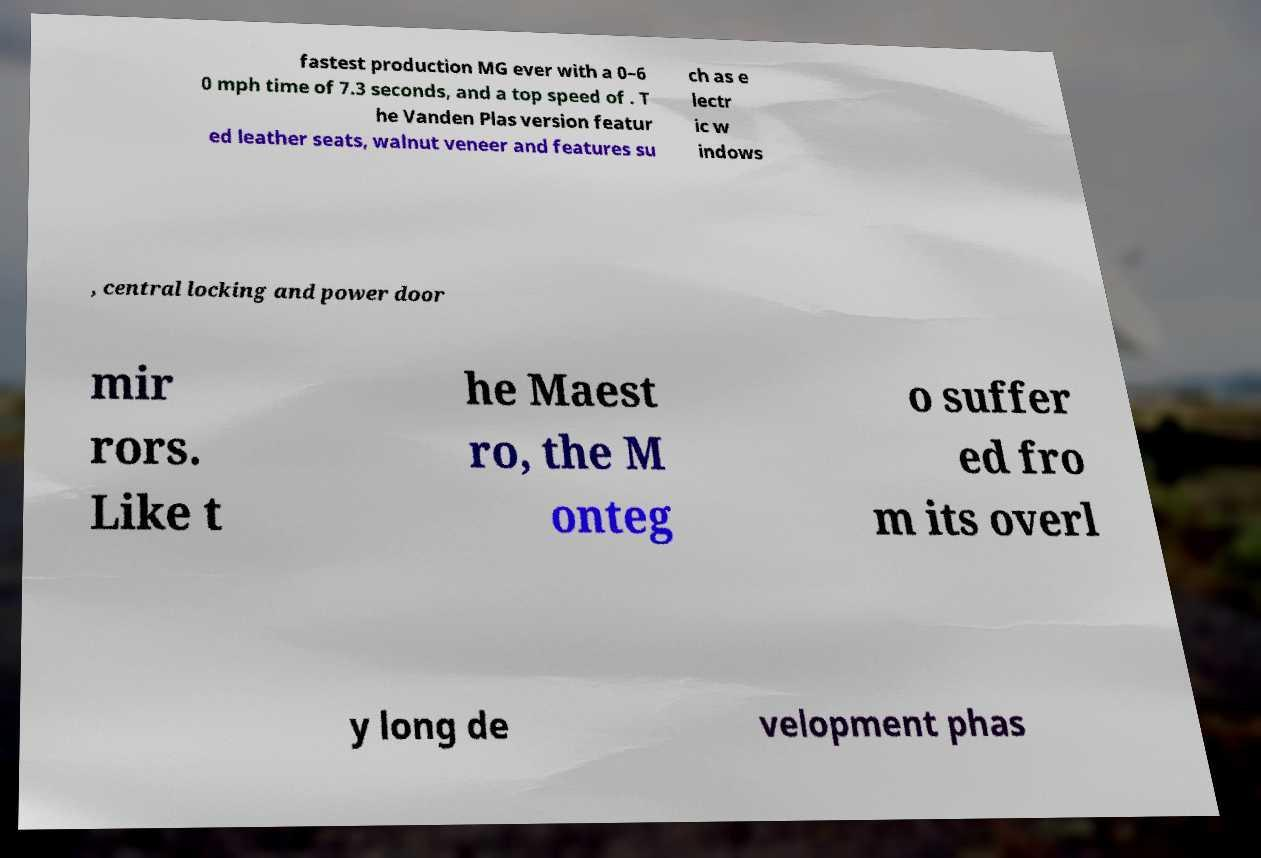Please read and relay the text visible in this image. What does it say? fastest production MG ever with a 0–6 0 mph time of 7.3 seconds, and a top speed of . T he Vanden Plas version featur ed leather seats, walnut veneer and features su ch as e lectr ic w indows , central locking and power door mir rors. Like t he Maest ro, the M onteg o suffer ed fro m its overl y long de velopment phas 